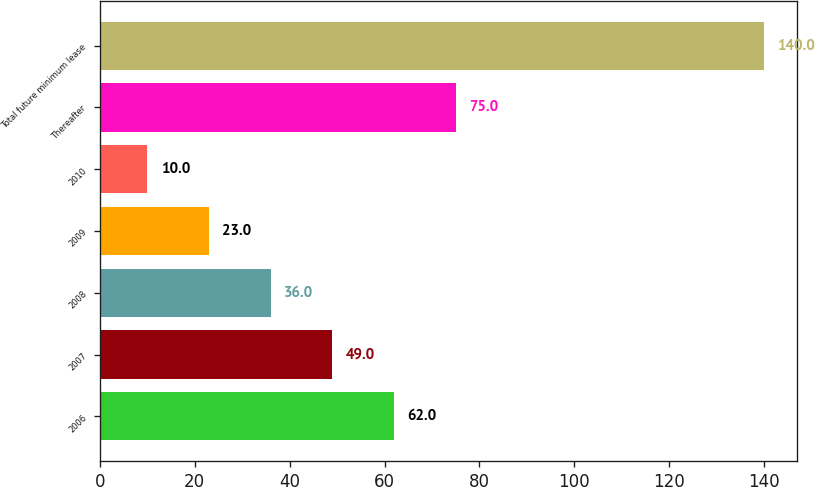Convert chart to OTSL. <chart><loc_0><loc_0><loc_500><loc_500><bar_chart><fcel>2006<fcel>2007<fcel>2008<fcel>2009<fcel>2010<fcel>Thereafter<fcel>Total future minimum lease<nl><fcel>62<fcel>49<fcel>36<fcel>23<fcel>10<fcel>75<fcel>140<nl></chart> 